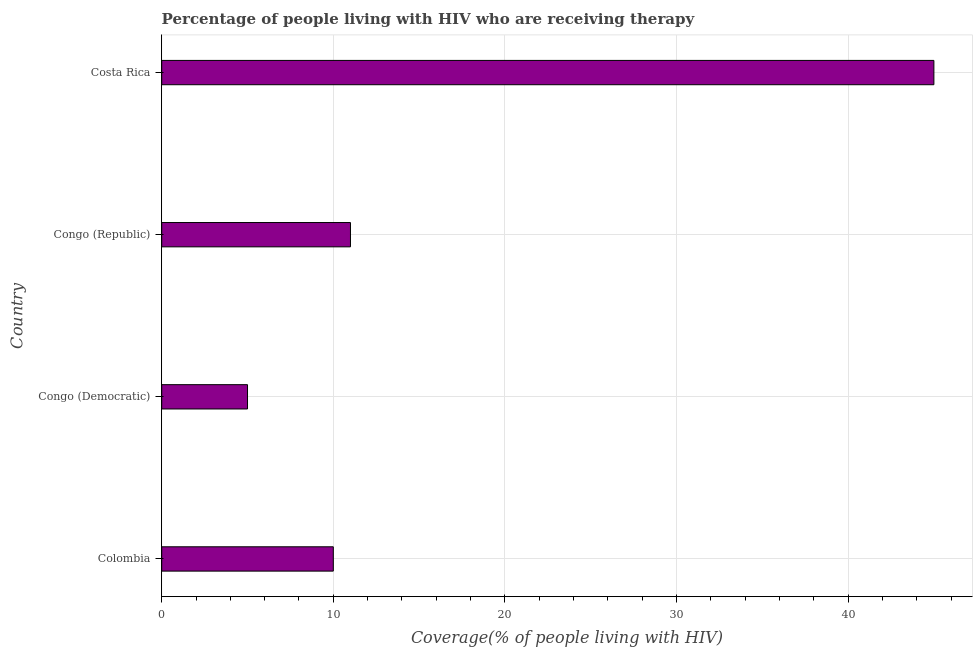Does the graph contain any zero values?
Your answer should be very brief. No. Does the graph contain grids?
Provide a short and direct response. Yes. What is the title of the graph?
Give a very brief answer. Percentage of people living with HIV who are receiving therapy. What is the label or title of the X-axis?
Give a very brief answer. Coverage(% of people living with HIV). Across all countries, what is the minimum antiretroviral therapy coverage?
Ensure brevity in your answer.  5. In which country was the antiretroviral therapy coverage minimum?
Keep it short and to the point. Congo (Democratic). What is the sum of the antiretroviral therapy coverage?
Provide a succinct answer. 71. What is the difference between the antiretroviral therapy coverage in Colombia and Congo (Democratic)?
Ensure brevity in your answer.  5. What is the average antiretroviral therapy coverage per country?
Ensure brevity in your answer.  17.75. What is the median antiretroviral therapy coverage?
Provide a short and direct response. 10.5. In how many countries, is the antiretroviral therapy coverage greater than 22 %?
Make the answer very short. 1. Is the difference between the antiretroviral therapy coverage in Colombia and Congo (Republic) greater than the difference between any two countries?
Provide a short and direct response. No. Is the sum of the antiretroviral therapy coverage in Colombia and Costa Rica greater than the maximum antiretroviral therapy coverage across all countries?
Keep it short and to the point. Yes. What is the difference between the highest and the lowest antiretroviral therapy coverage?
Your response must be concise. 40. How many bars are there?
Ensure brevity in your answer.  4. How many countries are there in the graph?
Offer a terse response. 4. What is the difference between two consecutive major ticks on the X-axis?
Offer a very short reply. 10. What is the Coverage(% of people living with HIV) of Costa Rica?
Provide a succinct answer. 45. What is the difference between the Coverage(% of people living with HIV) in Colombia and Congo (Democratic)?
Keep it short and to the point. 5. What is the difference between the Coverage(% of people living with HIV) in Colombia and Congo (Republic)?
Your response must be concise. -1. What is the difference between the Coverage(% of people living with HIV) in Colombia and Costa Rica?
Your response must be concise. -35. What is the difference between the Coverage(% of people living with HIV) in Congo (Democratic) and Costa Rica?
Your answer should be very brief. -40. What is the difference between the Coverage(% of people living with HIV) in Congo (Republic) and Costa Rica?
Your response must be concise. -34. What is the ratio of the Coverage(% of people living with HIV) in Colombia to that in Congo (Republic)?
Your response must be concise. 0.91. What is the ratio of the Coverage(% of people living with HIV) in Colombia to that in Costa Rica?
Your response must be concise. 0.22. What is the ratio of the Coverage(% of people living with HIV) in Congo (Democratic) to that in Congo (Republic)?
Keep it short and to the point. 0.46. What is the ratio of the Coverage(% of people living with HIV) in Congo (Democratic) to that in Costa Rica?
Provide a short and direct response. 0.11. What is the ratio of the Coverage(% of people living with HIV) in Congo (Republic) to that in Costa Rica?
Offer a terse response. 0.24. 